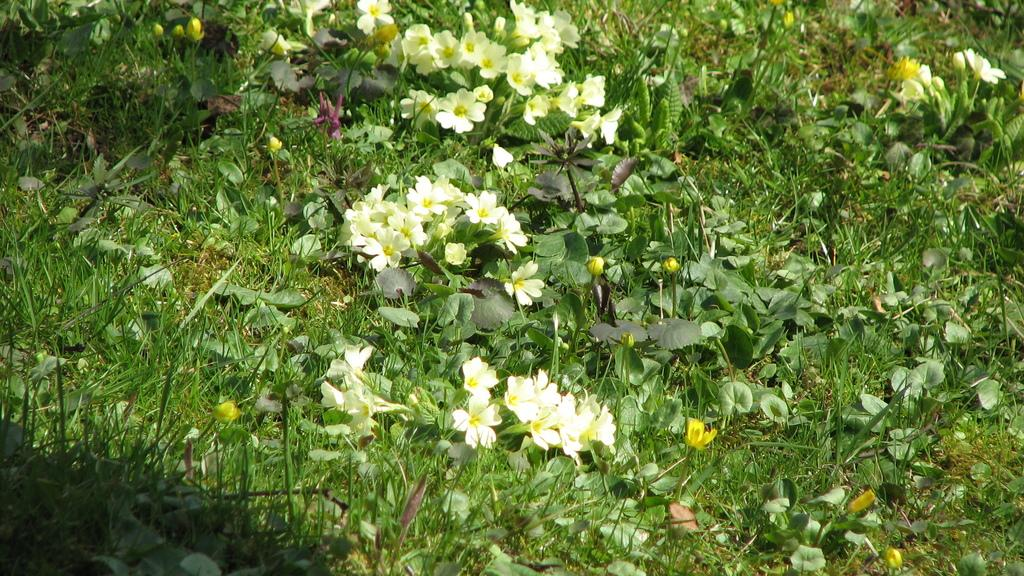What type of flora is present in the image? There are flowers in the image. What color are the flowers? The flowers are white. What else can be seen on the ground in the image? There are plants on the ground. What type of vegetation covers the ground in the image? The ground is covered with grass. What type of toys are being used in the story depicted in the image? There is no story or toys present in the image; it features flowers, plants, and grass. 